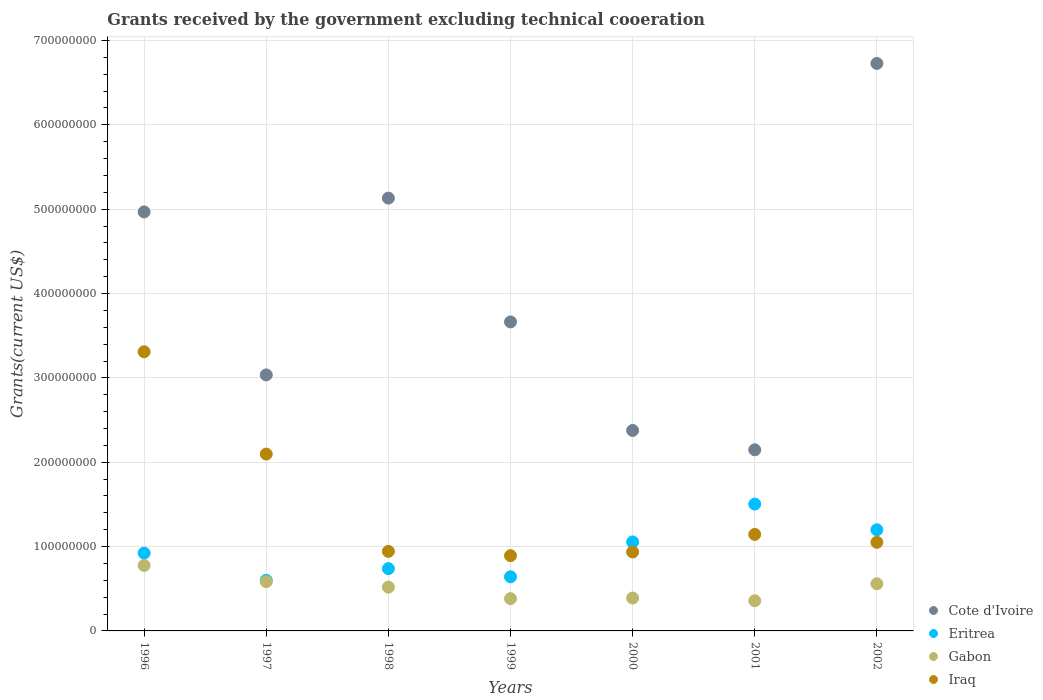How many different coloured dotlines are there?
Offer a terse response. 4. What is the total grants received by the government in Gabon in 1998?
Provide a succinct answer. 5.19e+07. Across all years, what is the maximum total grants received by the government in Iraq?
Your answer should be compact. 3.31e+08. Across all years, what is the minimum total grants received by the government in Eritrea?
Make the answer very short. 6.00e+07. In which year was the total grants received by the government in Iraq maximum?
Offer a terse response. 1996. What is the total total grants received by the government in Iraq in the graph?
Keep it short and to the point. 1.04e+09. What is the difference between the total grants received by the government in Gabon in 1998 and that in 1999?
Ensure brevity in your answer.  1.36e+07. What is the difference between the total grants received by the government in Eritrea in 1999 and the total grants received by the government in Gabon in 1996?
Offer a very short reply. -1.34e+07. What is the average total grants received by the government in Iraq per year?
Keep it short and to the point. 1.48e+08. In the year 2000, what is the difference between the total grants received by the government in Iraq and total grants received by the government in Gabon?
Your answer should be compact. 5.46e+07. What is the ratio of the total grants received by the government in Gabon in 1996 to that in 1999?
Ensure brevity in your answer.  2.03. Is the total grants received by the government in Gabon in 1997 less than that in 1998?
Ensure brevity in your answer.  No. What is the difference between the highest and the second highest total grants received by the government in Cote d'Ivoire?
Keep it short and to the point. 1.60e+08. What is the difference between the highest and the lowest total grants received by the government in Gabon?
Your answer should be compact. 4.18e+07. Is it the case that in every year, the sum of the total grants received by the government in Iraq and total grants received by the government in Eritrea  is greater than the total grants received by the government in Cote d'Ivoire?
Your answer should be compact. No. Does the total grants received by the government in Iraq monotonically increase over the years?
Your answer should be very brief. No. How many dotlines are there?
Make the answer very short. 4. How many years are there in the graph?
Offer a very short reply. 7. Are the values on the major ticks of Y-axis written in scientific E-notation?
Your response must be concise. No. Does the graph contain any zero values?
Make the answer very short. No. How are the legend labels stacked?
Keep it short and to the point. Vertical. What is the title of the graph?
Your response must be concise. Grants received by the government excluding technical cooeration. What is the label or title of the X-axis?
Offer a very short reply. Years. What is the label or title of the Y-axis?
Offer a very short reply. Grants(current US$). What is the Grants(current US$) in Cote d'Ivoire in 1996?
Offer a terse response. 4.97e+08. What is the Grants(current US$) in Eritrea in 1996?
Your answer should be very brief. 9.22e+07. What is the Grants(current US$) in Gabon in 1996?
Ensure brevity in your answer.  7.76e+07. What is the Grants(current US$) in Iraq in 1996?
Your answer should be very brief. 3.31e+08. What is the Grants(current US$) in Cote d'Ivoire in 1997?
Provide a short and direct response. 3.04e+08. What is the Grants(current US$) in Eritrea in 1997?
Ensure brevity in your answer.  6.00e+07. What is the Grants(current US$) in Gabon in 1997?
Provide a succinct answer. 5.84e+07. What is the Grants(current US$) in Iraq in 1997?
Your response must be concise. 2.10e+08. What is the Grants(current US$) in Cote d'Ivoire in 1998?
Offer a terse response. 5.13e+08. What is the Grants(current US$) of Eritrea in 1998?
Your answer should be very brief. 7.39e+07. What is the Grants(current US$) in Gabon in 1998?
Give a very brief answer. 5.19e+07. What is the Grants(current US$) of Iraq in 1998?
Give a very brief answer. 9.43e+07. What is the Grants(current US$) in Cote d'Ivoire in 1999?
Provide a succinct answer. 3.66e+08. What is the Grants(current US$) of Eritrea in 1999?
Offer a very short reply. 6.42e+07. What is the Grants(current US$) of Gabon in 1999?
Provide a succinct answer. 3.83e+07. What is the Grants(current US$) of Iraq in 1999?
Make the answer very short. 8.92e+07. What is the Grants(current US$) in Cote d'Ivoire in 2000?
Give a very brief answer. 2.38e+08. What is the Grants(current US$) in Eritrea in 2000?
Your answer should be compact. 1.06e+08. What is the Grants(current US$) in Gabon in 2000?
Your answer should be very brief. 3.90e+07. What is the Grants(current US$) of Iraq in 2000?
Your answer should be compact. 9.36e+07. What is the Grants(current US$) of Cote d'Ivoire in 2001?
Keep it short and to the point. 2.15e+08. What is the Grants(current US$) of Eritrea in 2001?
Ensure brevity in your answer.  1.50e+08. What is the Grants(current US$) of Gabon in 2001?
Provide a succinct answer. 3.58e+07. What is the Grants(current US$) of Iraq in 2001?
Ensure brevity in your answer.  1.14e+08. What is the Grants(current US$) of Cote d'Ivoire in 2002?
Your answer should be compact. 6.73e+08. What is the Grants(current US$) of Eritrea in 2002?
Keep it short and to the point. 1.20e+08. What is the Grants(current US$) of Gabon in 2002?
Keep it short and to the point. 5.59e+07. What is the Grants(current US$) of Iraq in 2002?
Your answer should be compact. 1.05e+08. Across all years, what is the maximum Grants(current US$) in Cote d'Ivoire?
Provide a short and direct response. 6.73e+08. Across all years, what is the maximum Grants(current US$) of Eritrea?
Ensure brevity in your answer.  1.50e+08. Across all years, what is the maximum Grants(current US$) in Gabon?
Your response must be concise. 7.76e+07. Across all years, what is the maximum Grants(current US$) of Iraq?
Ensure brevity in your answer.  3.31e+08. Across all years, what is the minimum Grants(current US$) of Cote d'Ivoire?
Keep it short and to the point. 2.15e+08. Across all years, what is the minimum Grants(current US$) in Eritrea?
Your answer should be compact. 6.00e+07. Across all years, what is the minimum Grants(current US$) of Gabon?
Provide a short and direct response. 3.58e+07. Across all years, what is the minimum Grants(current US$) in Iraq?
Offer a very short reply. 8.92e+07. What is the total Grants(current US$) in Cote d'Ivoire in the graph?
Ensure brevity in your answer.  2.81e+09. What is the total Grants(current US$) of Eritrea in the graph?
Ensure brevity in your answer.  6.66e+08. What is the total Grants(current US$) of Gabon in the graph?
Offer a terse response. 3.57e+08. What is the total Grants(current US$) of Iraq in the graph?
Your answer should be compact. 1.04e+09. What is the difference between the Grants(current US$) of Cote d'Ivoire in 1996 and that in 1997?
Your answer should be very brief. 1.93e+08. What is the difference between the Grants(current US$) of Eritrea in 1996 and that in 1997?
Ensure brevity in your answer.  3.22e+07. What is the difference between the Grants(current US$) in Gabon in 1996 and that in 1997?
Give a very brief answer. 1.92e+07. What is the difference between the Grants(current US$) in Iraq in 1996 and that in 1997?
Provide a succinct answer. 1.21e+08. What is the difference between the Grants(current US$) in Cote d'Ivoire in 1996 and that in 1998?
Your answer should be compact. -1.64e+07. What is the difference between the Grants(current US$) in Eritrea in 1996 and that in 1998?
Provide a short and direct response. 1.84e+07. What is the difference between the Grants(current US$) of Gabon in 1996 and that in 1998?
Keep it short and to the point. 2.57e+07. What is the difference between the Grants(current US$) in Iraq in 1996 and that in 1998?
Give a very brief answer. 2.37e+08. What is the difference between the Grants(current US$) of Cote d'Ivoire in 1996 and that in 1999?
Your answer should be compact. 1.30e+08. What is the difference between the Grants(current US$) in Eritrea in 1996 and that in 1999?
Offer a terse response. 2.81e+07. What is the difference between the Grants(current US$) of Gabon in 1996 and that in 1999?
Your response must be concise. 3.94e+07. What is the difference between the Grants(current US$) of Iraq in 1996 and that in 1999?
Your answer should be very brief. 2.42e+08. What is the difference between the Grants(current US$) of Cote d'Ivoire in 1996 and that in 2000?
Keep it short and to the point. 2.59e+08. What is the difference between the Grants(current US$) in Eritrea in 1996 and that in 2000?
Provide a succinct answer. -1.33e+07. What is the difference between the Grants(current US$) in Gabon in 1996 and that in 2000?
Keep it short and to the point. 3.86e+07. What is the difference between the Grants(current US$) of Iraq in 1996 and that in 2000?
Your answer should be compact. 2.37e+08. What is the difference between the Grants(current US$) of Cote d'Ivoire in 1996 and that in 2001?
Keep it short and to the point. 2.82e+08. What is the difference between the Grants(current US$) of Eritrea in 1996 and that in 2001?
Your answer should be compact. -5.82e+07. What is the difference between the Grants(current US$) in Gabon in 1996 and that in 2001?
Give a very brief answer. 4.18e+07. What is the difference between the Grants(current US$) of Iraq in 1996 and that in 2001?
Make the answer very short. 2.17e+08. What is the difference between the Grants(current US$) in Cote d'Ivoire in 1996 and that in 2002?
Provide a succinct answer. -1.76e+08. What is the difference between the Grants(current US$) in Eritrea in 1996 and that in 2002?
Keep it short and to the point. -2.77e+07. What is the difference between the Grants(current US$) of Gabon in 1996 and that in 2002?
Make the answer very short. 2.17e+07. What is the difference between the Grants(current US$) of Iraq in 1996 and that in 2002?
Give a very brief answer. 2.26e+08. What is the difference between the Grants(current US$) in Cote d'Ivoire in 1997 and that in 1998?
Ensure brevity in your answer.  -2.10e+08. What is the difference between the Grants(current US$) of Eritrea in 1997 and that in 1998?
Provide a short and direct response. -1.38e+07. What is the difference between the Grants(current US$) in Gabon in 1997 and that in 1998?
Your answer should be compact. 6.46e+06. What is the difference between the Grants(current US$) of Iraq in 1997 and that in 1998?
Your answer should be very brief. 1.15e+08. What is the difference between the Grants(current US$) in Cote d'Ivoire in 1997 and that in 1999?
Your answer should be very brief. -6.28e+07. What is the difference between the Grants(current US$) of Eritrea in 1997 and that in 1999?
Offer a terse response. -4.17e+06. What is the difference between the Grants(current US$) of Gabon in 1997 and that in 1999?
Keep it short and to the point. 2.01e+07. What is the difference between the Grants(current US$) in Iraq in 1997 and that in 1999?
Make the answer very short. 1.20e+08. What is the difference between the Grants(current US$) of Cote d'Ivoire in 1997 and that in 2000?
Your answer should be very brief. 6.59e+07. What is the difference between the Grants(current US$) of Eritrea in 1997 and that in 2000?
Your response must be concise. -4.55e+07. What is the difference between the Grants(current US$) of Gabon in 1997 and that in 2000?
Provide a succinct answer. 1.94e+07. What is the difference between the Grants(current US$) of Iraq in 1997 and that in 2000?
Offer a very short reply. 1.16e+08. What is the difference between the Grants(current US$) in Cote d'Ivoire in 1997 and that in 2001?
Offer a terse response. 8.88e+07. What is the difference between the Grants(current US$) of Eritrea in 1997 and that in 2001?
Offer a terse response. -9.04e+07. What is the difference between the Grants(current US$) of Gabon in 1997 and that in 2001?
Make the answer very short. 2.26e+07. What is the difference between the Grants(current US$) of Iraq in 1997 and that in 2001?
Provide a short and direct response. 9.52e+07. What is the difference between the Grants(current US$) of Cote d'Ivoire in 1997 and that in 2002?
Keep it short and to the point. -3.69e+08. What is the difference between the Grants(current US$) in Eritrea in 1997 and that in 2002?
Give a very brief answer. -5.99e+07. What is the difference between the Grants(current US$) in Gabon in 1997 and that in 2002?
Your answer should be very brief. 2.47e+06. What is the difference between the Grants(current US$) in Iraq in 1997 and that in 2002?
Keep it short and to the point. 1.05e+08. What is the difference between the Grants(current US$) in Cote d'Ivoire in 1998 and that in 1999?
Your answer should be compact. 1.47e+08. What is the difference between the Grants(current US$) in Eritrea in 1998 and that in 1999?
Offer a very short reply. 9.68e+06. What is the difference between the Grants(current US$) in Gabon in 1998 and that in 1999?
Your answer should be very brief. 1.36e+07. What is the difference between the Grants(current US$) of Iraq in 1998 and that in 1999?
Your response must be concise. 5.11e+06. What is the difference between the Grants(current US$) of Cote d'Ivoire in 1998 and that in 2000?
Give a very brief answer. 2.75e+08. What is the difference between the Grants(current US$) in Eritrea in 1998 and that in 2000?
Your answer should be very brief. -3.17e+07. What is the difference between the Grants(current US$) in Gabon in 1998 and that in 2000?
Offer a terse response. 1.29e+07. What is the difference between the Grants(current US$) of Iraq in 1998 and that in 2000?
Make the answer very short. 7.00e+05. What is the difference between the Grants(current US$) of Cote d'Ivoire in 1998 and that in 2001?
Offer a terse response. 2.98e+08. What is the difference between the Grants(current US$) in Eritrea in 1998 and that in 2001?
Your answer should be compact. -7.66e+07. What is the difference between the Grants(current US$) of Gabon in 1998 and that in 2001?
Your response must be concise. 1.61e+07. What is the difference between the Grants(current US$) in Iraq in 1998 and that in 2001?
Offer a very short reply. -2.01e+07. What is the difference between the Grants(current US$) of Cote d'Ivoire in 1998 and that in 2002?
Provide a succinct answer. -1.60e+08. What is the difference between the Grants(current US$) of Eritrea in 1998 and that in 2002?
Your answer should be compact. -4.61e+07. What is the difference between the Grants(current US$) of Gabon in 1998 and that in 2002?
Give a very brief answer. -3.99e+06. What is the difference between the Grants(current US$) in Iraq in 1998 and that in 2002?
Offer a very short reply. -1.07e+07. What is the difference between the Grants(current US$) in Cote d'Ivoire in 1999 and that in 2000?
Ensure brevity in your answer.  1.29e+08. What is the difference between the Grants(current US$) of Eritrea in 1999 and that in 2000?
Your response must be concise. -4.13e+07. What is the difference between the Grants(current US$) of Gabon in 1999 and that in 2000?
Your answer should be very brief. -7.00e+05. What is the difference between the Grants(current US$) of Iraq in 1999 and that in 2000?
Give a very brief answer. -4.41e+06. What is the difference between the Grants(current US$) of Cote d'Ivoire in 1999 and that in 2001?
Ensure brevity in your answer.  1.52e+08. What is the difference between the Grants(current US$) in Eritrea in 1999 and that in 2001?
Keep it short and to the point. -8.62e+07. What is the difference between the Grants(current US$) of Gabon in 1999 and that in 2001?
Offer a very short reply. 2.50e+06. What is the difference between the Grants(current US$) in Iraq in 1999 and that in 2001?
Offer a terse response. -2.52e+07. What is the difference between the Grants(current US$) in Cote d'Ivoire in 1999 and that in 2002?
Your response must be concise. -3.06e+08. What is the difference between the Grants(current US$) in Eritrea in 1999 and that in 2002?
Your response must be concise. -5.58e+07. What is the difference between the Grants(current US$) of Gabon in 1999 and that in 2002?
Your answer should be very brief. -1.76e+07. What is the difference between the Grants(current US$) in Iraq in 1999 and that in 2002?
Your response must be concise. -1.58e+07. What is the difference between the Grants(current US$) in Cote d'Ivoire in 2000 and that in 2001?
Give a very brief answer. 2.30e+07. What is the difference between the Grants(current US$) of Eritrea in 2000 and that in 2001?
Make the answer very short. -4.49e+07. What is the difference between the Grants(current US$) in Gabon in 2000 and that in 2001?
Your answer should be very brief. 3.20e+06. What is the difference between the Grants(current US$) of Iraq in 2000 and that in 2001?
Keep it short and to the point. -2.08e+07. What is the difference between the Grants(current US$) in Cote d'Ivoire in 2000 and that in 2002?
Provide a succinct answer. -4.35e+08. What is the difference between the Grants(current US$) of Eritrea in 2000 and that in 2002?
Keep it short and to the point. -1.44e+07. What is the difference between the Grants(current US$) of Gabon in 2000 and that in 2002?
Offer a terse response. -1.69e+07. What is the difference between the Grants(current US$) in Iraq in 2000 and that in 2002?
Give a very brief answer. -1.14e+07. What is the difference between the Grants(current US$) of Cote d'Ivoire in 2001 and that in 2002?
Keep it short and to the point. -4.58e+08. What is the difference between the Grants(current US$) in Eritrea in 2001 and that in 2002?
Make the answer very short. 3.05e+07. What is the difference between the Grants(current US$) in Gabon in 2001 and that in 2002?
Give a very brief answer. -2.01e+07. What is the difference between the Grants(current US$) in Iraq in 2001 and that in 2002?
Offer a very short reply. 9.41e+06. What is the difference between the Grants(current US$) in Cote d'Ivoire in 1996 and the Grants(current US$) in Eritrea in 1997?
Ensure brevity in your answer.  4.37e+08. What is the difference between the Grants(current US$) in Cote d'Ivoire in 1996 and the Grants(current US$) in Gabon in 1997?
Your answer should be compact. 4.38e+08. What is the difference between the Grants(current US$) of Cote d'Ivoire in 1996 and the Grants(current US$) of Iraq in 1997?
Ensure brevity in your answer.  2.87e+08. What is the difference between the Grants(current US$) of Eritrea in 1996 and the Grants(current US$) of Gabon in 1997?
Your answer should be compact. 3.39e+07. What is the difference between the Grants(current US$) of Eritrea in 1996 and the Grants(current US$) of Iraq in 1997?
Offer a very short reply. -1.17e+08. What is the difference between the Grants(current US$) of Gabon in 1996 and the Grants(current US$) of Iraq in 1997?
Ensure brevity in your answer.  -1.32e+08. What is the difference between the Grants(current US$) in Cote d'Ivoire in 1996 and the Grants(current US$) in Eritrea in 1998?
Provide a short and direct response. 4.23e+08. What is the difference between the Grants(current US$) of Cote d'Ivoire in 1996 and the Grants(current US$) of Gabon in 1998?
Provide a succinct answer. 4.45e+08. What is the difference between the Grants(current US$) in Cote d'Ivoire in 1996 and the Grants(current US$) in Iraq in 1998?
Your answer should be compact. 4.02e+08. What is the difference between the Grants(current US$) of Eritrea in 1996 and the Grants(current US$) of Gabon in 1998?
Your response must be concise. 4.03e+07. What is the difference between the Grants(current US$) in Eritrea in 1996 and the Grants(current US$) in Iraq in 1998?
Provide a short and direct response. -2.05e+06. What is the difference between the Grants(current US$) of Gabon in 1996 and the Grants(current US$) of Iraq in 1998?
Give a very brief answer. -1.67e+07. What is the difference between the Grants(current US$) in Cote d'Ivoire in 1996 and the Grants(current US$) in Eritrea in 1999?
Your answer should be very brief. 4.33e+08. What is the difference between the Grants(current US$) of Cote d'Ivoire in 1996 and the Grants(current US$) of Gabon in 1999?
Give a very brief answer. 4.58e+08. What is the difference between the Grants(current US$) in Cote d'Ivoire in 1996 and the Grants(current US$) in Iraq in 1999?
Your answer should be compact. 4.08e+08. What is the difference between the Grants(current US$) of Eritrea in 1996 and the Grants(current US$) of Gabon in 1999?
Offer a terse response. 5.40e+07. What is the difference between the Grants(current US$) of Eritrea in 1996 and the Grants(current US$) of Iraq in 1999?
Provide a short and direct response. 3.06e+06. What is the difference between the Grants(current US$) of Gabon in 1996 and the Grants(current US$) of Iraq in 1999?
Your answer should be compact. -1.16e+07. What is the difference between the Grants(current US$) in Cote d'Ivoire in 1996 and the Grants(current US$) in Eritrea in 2000?
Provide a succinct answer. 3.91e+08. What is the difference between the Grants(current US$) in Cote d'Ivoire in 1996 and the Grants(current US$) in Gabon in 2000?
Provide a short and direct response. 4.58e+08. What is the difference between the Grants(current US$) of Cote d'Ivoire in 1996 and the Grants(current US$) of Iraq in 2000?
Provide a succinct answer. 4.03e+08. What is the difference between the Grants(current US$) of Eritrea in 1996 and the Grants(current US$) of Gabon in 2000?
Your answer should be very brief. 5.33e+07. What is the difference between the Grants(current US$) in Eritrea in 1996 and the Grants(current US$) in Iraq in 2000?
Give a very brief answer. -1.35e+06. What is the difference between the Grants(current US$) in Gabon in 1996 and the Grants(current US$) in Iraq in 2000?
Provide a short and direct response. -1.60e+07. What is the difference between the Grants(current US$) in Cote d'Ivoire in 1996 and the Grants(current US$) in Eritrea in 2001?
Offer a terse response. 3.46e+08. What is the difference between the Grants(current US$) of Cote d'Ivoire in 1996 and the Grants(current US$) of Gabon in 2001?
Offer a very short reply. 4.61e+08. What is the difference between the Grants(current US$) of Cote d'Ivoire in 1996 and the Grants(current US$) of Iraq in 2001?
Offer a terse response. 3.82e+08. What is the difference between the Grants(current US$) in Eritrea in 1996 and the Grants(current US$) in Gabon in 2001?
Your response must be concise. 5.65e+07. What is the difference between the Grants(current US$) in Eritrea in 1996 and the Grants(current US$) in Iraq in 2001?
Your answer should be compact. -2.22e+07. What is the difference between the Grants(current US$) of Gabon in 1996 and the Grants(current US$) of Iraq in 2001?
Provide a short and direct response. -3.68e+07. What is the difference between the Grants(current US$) of Cote d'Ivoire in 1996 and the Grants(current US$) of Eritrea in 2002?
Your response must be concise. 3.77e+08. What is the difference between the Grants(current US$) in Cote d'Ivoire in 1996 and the Grants(current US$) in Gabon in 2002?
Offer a very short reply. 4.41e+08. What is the difference between the Grants(current US$) in Cote d'Ivoire in 1996 and the Grants(current US$) in Iraq in 2002?
Your answer should be compact. 3.92e+08. What is the difference between the Grants(current US$) of Eritrea in 1996 and the Grants(current US$) of Gabon in 2002?
Make the answer very short. 3.63e+07. What is the difference between the Grants(current US$) in Eritrea in 1996 and the Grants(current US$) in Iraq in 2002?
Ensure brevity in your answer.  -1.28e+07. What is the difference between the Grants(current US$) of Gabon in 1996 and the Grants(current US$) of Iraq in 2002?
Your response must be concise. -2.74e+07. What is the difference between the Grants(current US$) of Cote d'Ivoire in 1997 and the Grants(current US$) of Eritrea in 1998?
Provide a short and direct response. 2.30e+08. What is the difference between the Grants(current US$) in Cote d'Ivoire in 1997 and the Grants(current US$) in Gabon in 1998?
Offer a very short reply. 2.52e+08. What is the difference between the Grants(current US$) in Cote d'Ivoire in 1997 and the Grants(current US$) in Iraq in 1998?
Provide a succinct answer. 2.09e+08. What is the difference between the Grants(current US$) of Eritrea in 1997 and the Grants(current US$) of Gabon in 1998?
Your response must be concise. 8.09e+06. What is the difference between the Grants(current US$) of Eritrea in 1997 and the Grants(current US$) of Iraq in 1998?
Keep it short and to the point. -3.43e+07. What is the difference between the Grants(current US$) in Gabon in 1997 and the Grants(current US$) in Iraq in 1998?
Provide a short and direct response. -3.59e+07. What is the difference between the Grants(current US$) in Cote d'Ivoire in 1997 and the Grants(current US$) in Eritrea in 1999?
Offer a very short reply. 2.39e+08. What is the difference between the Grants(current US$) of Cote d'Ivoire in 1997 and the Grants(current US$) of Gabon in 1999?
Offer a terse response. 2.65e+08. What is the difference between the Grants(current US$) of Cote d'Ivoire in 1997 and the Grants(current US$) of Iraq in 1999?
Provide a short and direct response. 2.14e+08. What is the difference between the Grants(current US$) in Eritrea in 1997 and the Grants(current US$) in Gabon in 1999?
Your answer should be very brief. 2.17e+07. What is the difference between the Grants(current US$) in Eritrea in 1997 and the Grants(current US$) in Iraq in 1999?
Your answer should be compact. -2.92e+07. What is the difference between the Grants(current US$) of Gabon in 1997 and the Grants(current US$) of Iraq in 1999?
Ensure brevity in your answer.  -3.08e+07. What is the difference between the Grants(current US$) in Cote d'Ivoire in 1997 and the Grants(current US$) in Eritrea in 2000?
Offer a terse response. 1.98e+08. What is the difference between the Grants(current US$) of Cote d'Ivoire in 1997 and the Grants(current US$) of Gabon in 2000?
Ensure brevity in your answer.  2.65e+08. What is the difference between the Grants(current US$) of Cote d'Ivoire in 1997 and the Grants(current US$) of Iraq in 2000?
Ensure brevity in your answer.  2.10e+08. What is the difference between the Grants(current US$) of Eritrea in 1997 and the Grants(current US$) of Gabon in 2000?
Keep it short and to the point. 2.10e+07. What is the difference between the Grants(current US$) in Eritrea in 1997 and the Grants(current US$) in Iraq in 2000?
Your answer should be compact. -3.36e+07. What is the difference between the Grants(current US$) in Gabon in 1997 and the Grants(current US$) in Iraq in 2000?
Provide a succinct answer. -3.52e+07. What is the difference between the Grants(current US$) of Cote d'Ivoire in 1997 and the Grants(current US$) of Eritrea in 2001?
Ensure brevity in your answer.  1.53e+08. What is the difference between the Grants(current US$) in Cote d'Ivoire in 1997 and the Grants(current US$) in Gabon in 2001?
Provide a short and direct response. 2.68e+08. What is the difference between the Grants(current US$) in Cote d'Ivoire in 1997 and the Grants(current US$) in Iraq in 2001?
Keep it short and to the point. 1.89e+08. What is the difference between the Grants(current US$) of Eritrea in 1997 and the Grants(current US$) of Gabon in 2001?
Provide a succinct answer. 2.42e+07. What is the difference between the Grants(current US$) in Eritrea in 1997 and the Grants(current US$) in Iraq in 2001?
Provide a short and direct response. -5.44e+07. What is the difference between the Grants(current US$) in Gabon in 1997 and the Grants(current US$) in Iraq in 2001?
Give a very brief answer. -5.61e+07. What is the difference between the Grants(current US$) in Cote d'Ivoire in 1997 and the Grants(current US$) in Eritrea in 2002?
Keep it short and to the point. 1.84e+08. What is the difference between the Grants(current US$) in Cote d'Ivoire in 1997 and the Grants(current US$) in Gabon in 2002?
Your response must be concise. 2.48e+08. What is the difference between the Grants(current US$) in Cote d'Ivoire in 1997 and the Grants(current US$) in Iraq in 2002?
Offer a terse response. 1.99e+08. What is the difference between the Grants(current US$) in Eritrea in 1997 and the Grants(current US$) in Gabon in 2002?
Your answer should be very brief. 4.10e+06. What is the difference between the Grants(current US$) of Eritrea in 1997 and the Grants(current US$) of Iraq in 2002?
Make the answer very short. -4.50e+07. What is the difference between the Grants(current US$) in Gabon in 1997 and the Grants(current US$) in Iraq in 2002?
Your answer should be compact. -4.66e+07. What is the difference between the Grants(current US$) in Cote d'Ivoire in 1998 and the Grants(current US$) in Eritrea in 1999?
Make the answer very short. 4.49e+08. What is the difference between the Grants(current US$) in Cote d'Ivoire in 1998 and the Grants(current US$) in Gabon in 1999?
Offer a very short reply. 4.75e+08. What is the difference between the Grants(current US$) of Cote d'Ivoire in 1998 and the Grants(current US$) of Iraq in 1999?
Offer a very short reply. 4.24e+08. What is the difference between the Grants(current US$) in Eritrea in 1998 and the Grants(current US$) in Gabon in 1999?
Your answer should be very brief. 3.56e+07. What is the difference between the Grants(current US$) in Eritrea in 1998 and the Grants(current US$) in Iraq in 1999?
Offer a very short reply. -1.53e+07. What is the difference between the Grants(current US$) of Gabon in 1998 and the Grants(current US$) of Iraq in 1999?
Offer a very short reply. -3.73e+07. What is the difference between the Grants(current US$) of Cote d'Ivoire in 1998 and the Grants(current US$) of Eritrea in 2000?
Your response must be concise. 4.08e+08. What is the difference between the Grants(current US$) in Cote d'Ivoire in 1998 and the Grants(current US$) in Gabon in 2000?
Your answer should be compact. 4.74e+08. What is the difference between the Grants(current US$) of Cote d'Ivoire in 1998 and the Grants(current US$) of Iraq in 2000?
Keep it short and to the point. 4.20e+08. What is the difference between the Grants(current US$) of Eritrea in 1998 and the Grants(current US$) of Gabon in 2000?
Your answer should be very brief. 3.49e+07. What is the difference between the Grants(current US$) in Eritrea in 1998 and the Grants(current US$) in Iraq in 2000?
Offer a terse response. -1.97e+07. What is the difference between the Grants(current US$) of Gabon in 1998 and the Grants(current US$) of Iraq in 2000?
Give a very brief answer. -4.17e+07. What is the difference between the Grants(current US$) of Cote d'Ivoire in 1998 and the Grants(current US$) of Eritrea in 2001?
Keep it short and to the point. 3.63e+08. What is the difference between the Grants(current US$) in Cote d'Ivoire in 1998 and the Grants(current US$) in Gabon in 2001?
Your response must be concise. 4.77e+08. What is the difference between the Grants(current US$) in Cote d'Ivoire in 1998 and the Grants(current US$) in Iraq in 2001?
Give a very brief answer. 3.99e+08. What is the difference between the Grants(current US$) in Eritrea in 1998 and the Grants(current US$) in Gabon in 2001?
Keep it short and to the point. 3.81e+07. What is the difference between the Grants(current US$) of Eritrea in 1998 and the Grants(current US$) of Iraq in 2001?
Keep it short and to the point. -4.06e+07. What is the difference between the Grants(current US$) in Gabon in 1998 and the Grants(current US$) in Iraq in 2001?
Keep it short and to the point. -6.25e+07. What is the difference between the Grants(current US$) in Cote d'Ivoire in 1998 and the Grants(current US$) in Eritrea in 2002?
Give a very brief answer. 3.93e+08. What is the difference between the Grants(current US$) in Cote d'Ivoire in 1998 and the Grants(current US$) in Gabon in 2002?
Offer a very short reply. 4.57e+08. What is the difference between the Grants(current US$) of Cote d'Ivoire in 1998 and the Grants(current US$) of Iraq in 2002?
Make the answer very short. 4.08e+08. What is the difference between the Grants(current US$) in Eritrea in 1998 and the Grants(current US$) in Gabon in 2002?
Provide a short and direct response. 1.80e+07. What is the difference between the Grants(current US$) in Eritrea in 1998 and the Grants(current US$) in Iraq in 2002?
Ensure brevity in your answer.  -3.12e+07. What is the difference between the Grants(current US$) of Gabon in 1998 and the Grants(current US$) of Iraq in 2002?
Offer a very short reply. -5.31e+07. What is the difference between the Grants(current US$) of Cote d'Ivoire in 1999 and the Grants(current US$) of Eritrea in 2000?
Make the answer very short. 2.61e+08. What is the difference between the Grants(current US$) in Cote d'Ivoire in 1999 and the Grants(current US$) in Gabon in 2000?
Offer a very short reply. 3.27e+08. What is the difference between the Grants(current US$) in Cote d'Ivoire in 1999 and the Grants(current US$) in Iraq in 2000?
Provide a succinct answer. 2.73e+08. What is the difference between the Grants(current US$) in Eritrea in 1999 and the Grants(current US$) in Gabon in 2000?
Provide a succinct answer. 2.52e+07. What is the difference between the Grants(current US$) of Eritrea in 1999 and the Grants(current US$) of Iraq in 2000?
Your answer should be very brief. -2.94e+07. What is the difference between the Grants(current US$) of Gabon in 1999 and the Grants(current US$) of Iraq in 2000?
Ensure brevity in your answer.  -5.53e+07. What is the difference between the Grants(current US$) of Cote d'Ivoire in 1999 and the Grants(current US$) of Eritrea in 2001?
Your response must be concise. 2.16e+08. What is the difference between the Grants(current US$) of Cote d'Ivoire in 1999 and the Grants(current US$) of Gabon in 2001?
Your answer should be very brief. 3.31e+08. What is the difference between the Grants(current US$) of Cote d'Ivoire in 1999 and the Grants(current US$) of Iraq in 2001?
Keep it short and to the point. 2.52e+08. What is the difference between the Grants(current US$) in Eritrea in 1999 and the Grants(current US$) in Gabon in 2001?
Offer a terse response. 2.84e+07. What is the difference between the Grants(current US$) in Eritrea in 1999 and the Grants(current US$) in Iraq in 2001?
Your answer should be compact. -5.03e+07. What is the difference between the Grants(current US$) of Gabon in 1999 and the Grants(current US$) of Iraq in 2001?
Give a very brief answer. -7.62e+07. What is the difference between the Grants(current US$) in Cote d'Ivoire in 1999 and the Grants(current US$) in Eritrea in 2002?
Your response must be concise. 2.46e+08. What is the difference between the Grants(current US$) in Cote d'Ivoire in 1999 and the Grants(current US$) in Gabon in 2002?
Ensure brevity in your answer.  3.10e+08. What is the difference between the Grants(current US$) in Cote d'Ivoire in 1999 and the Grants(current US$) in Iraq in 2002?
Ensure brevity in your answer.  2.61e+08. What is the difference between the Grants(current US$) in Eritrea in 1999 and the Grants(current US$) in Gabon in 2002?
Give a very brief answer. 8.27e+06. What is the difference between the Grants(current US$) in Eritrea in 1999 and the Grants(current US$) in Iraq in 2002?
Your response must be concise. -4.08e+07. What is the difference between the Grants(current US$) of Gabon in 1999 and the Grants(current US$) of Iraq in 2002?
Offer a terse response. -6.68e+07. What is the difference between the Grants(current US$) of Cote d'Ivoire in 2000 and the Grants(current US$) of Eritrea in 2001?
Your answer should be very brief. 8.73e+07. What is the difference between the Grants(current US$) in Cote d'Ivoire in 2000 and the Grants(current US$) in Gabon in 2001?
Offer a terse response. 2.02e+08. What is the difference between the Grants(current US$) of Cote d'Ivoire in 2000 and the Grants(current US$) of Iraq in 2001?
Offer a terse response. 1.23e+08. What is the difference between the Grants(current US$) in Eritrea in 2000 and the Grants(current US$) in Gabon in 2001?
Ensure brevity in your answer.  6.97e+07. What is the difference between the Grants(current US$) of Eritrea in 2000 and the Grants(current US$) of Iraq in 2001?
Offer a terse response. -8.92e+06. What is the difference between the Grants(current US$) of Gabon in 2000 and the Grants(current US$) of Iraq in 2001?
Provide a succinct answer. -7.55e+07. What is the difference between the Grants(current US$) of Cote d'Ivoire in 2000 and the Grants(current US$) of Eritrea in 2002?
Offer a terse response. 1.18e+08. What is the difference between the Grants(current US$) in Cote d'Ivoire in 2000 and the Grants(current US$) in Gabon in 2002?
Make the answer very short. 1.82e+08. What is the difference between the Grants(current US$) in Cote d'Ivoire in 2000 and the Grants(current US$) in Iraq in 2002?
Provide a short and direct response. 1.33e+08. What is the difference between the Grants(current US$) in Eritrea in 2000 and the Grants(current US$) in Gabon in 2002?
Give a very brief answer. 4.96e+07. What is the difference between the Grants(current US$) in Gabon in 2000 and the Grants(current US$) in Iraq in 2002?
Your response must be concise. -6.60e+07. What is the difference between the Grants(current US$) of Cote d'Ivoire in 2001 and the Grants(current US$) of Eritrea in 2002?
Offer a very short reply. 9.48e+07. What is the difference between the Grants(current US$) in Cote d'Ivoire in 2001 and the Grants(current US$) in Gabon in 2002?
Keep it short and to the point. 1.59e+08. What is the difference between the Grants(current US$) of Cote d'Ivoire in 2001 and the Grants(current US$) of Iraq in 2002?
Provide a succinct answer. 1.10e+08. What is the difference between the Grants(current US$) in Eritrea in 2001 and the Grants(current US$) in Gabon in 2002?
Keep it short and to the point. 9.45e+07. What is the difference between the Grants(current US$) of Eritrea in 2001 and the Grants(current US$) of Iraq in 2002?
Give a very brief answer. 4.54e+07. What is the difference between the Grants(current US$) of Gabon in 2001 and the Grants(current US$) of Iraq in 2002?
Make the answer very short. -6.92e+07. What is the average Grants(current US$) in Cote d'Ivoire per year?
Ensure brevity in your answer.  4.01e+08. What is the average Grants(current US$) of Eritrea per year?
Offer a very short reply. 9.52e+07. What is the average Grants(current US$) in Gabon per year?
Give a very brief answer. 5.10e+07. What is the average Grants(current US$) of Iraq per year?
Make the answer very short. 1.48e+08. In the year 1996, what is the difference between the Grants(current US$) of Cote d'Ivoire and Grants(current US$) of Eritrea?
Ensure brevity in your answer.  4.05e+08. In the year 1996, what is the difference between the Grants(current US$) of Cote d'Ivoire and Grants(current US$) of Gabon?
Make the answer very short. 4.19e+08. In the year 1996, what is the difference between the Grants(current US$) of Cote d'Ivoire and Grants(current US$) of Iraq?
Your response must be concise. 1.66e+08. In the year 1996, what is the difference between the Grants(current US$) in Eritrea and Grants(current US$) in Gabon?
Your answer should be compact. 1.46e+07. In the year 1996, what is the difference between the Grants(current US$) in Eritrea and Grants(current US$) in Iraq?
Your answer should be very brief. -2.39e+08. In the year 1996, what is the difference between the Grants(current US$) of Gabon and Grants(current US$) of Iraq?
Make the answer very short. -2.53e+08. In the year 1997, what is the difference between the Grants(current US$) in Cote d'Ivoire and Grants(current US$) in Eritrea?
Your answer should be very brief. 2.44e+08. In the year 1997, what is the difference between the Grants(current US$) of Cote d'Ivoire and Grants(current US$) of Gabon?
Keep it short and to the point. 2.45e+08. In the year 1997, what is the difference between the Grants(current US$) in Cote d'Ivoire and Grants(current US$) in Iraq?
Make the answer very short. 9.39e+07. In the year 1997, what is the difference between the Grants(current US$) of Eritrea and Grants(current US$) of Gabon?
Your response must be concise. 1.63e+06. In the year 1997, what is the difference between the Grants(current US$) in Eritrea and Grants(current US$) in Iraq?
Ensure brevity in your answer.  -1.50e+08. In the year 1997, what is the difference between the Grants(current US$) in Gabon and Grants(current US$) in Iraq?
Provide a succinct answer. -1.51e+08. In the year 1998, what is the difference between the Grants(current US$) of Cote d'Ivoire and Grants(current US$) of Eritrea?
Offer a very short reply. 4.39e+08. In the year 1998, what is the difference between the Grants(current US$) in Cote d'Ivoire and Grants(current US$) in Gabon?
Your answer should be compact. 4.61e+08. In the year 1998, what is the difference between the Grants(current US$) in Cote d'Ivoire and Grants(current US$) in Iraq?
Your answer should be compact. 4.19e+08. In the year 1998, what is the difference between the Grants(current US$) of Eritrea and Grants(current US$) of Gabon?
Provide a succinct answer. 2.19e+07. In the year 1998, what is the difference between the Grants(current US$) of Eritrea and Grants(current US$) of Iraq?
Keep it short and to the point. -2.04e+07. In the year 1998, what is the difference between the Grants(current US$) in Gabon and Grants(current US$) in Iraq?
Your response must be concise. -4.24e+07. In the year 1999, what is the difference between the Grants(current US$) in Cote d'Ivoire and Grants(current US$) in Eritrea?
Provide a succinct answer. 3.02e+08. In the year 1999, what is the difference between the Grants(current US$) of Cote d'Ivoire and Grants(current US$) of Gabon?
Keep it short and to the point. 3.28e+08. In the year 1999, what is the difference between the Grants(current US$) of Cote d'Ivoire and Grants(current US$) of Iraq?
Your answer should be very brief. 2.77e+08. In the year 1999, what is the difference between the Grants(current US$) in Eritrea and Grants(current US$) in Gabon?
Ensure brevity in your answer.  2.59e+07. In the year 1999, what is the difference between the Grants(current US$) of Eritrea and Grants(current US$) of Iraq?
Your answer should be compact. -2.50e+07. In the year 1999, what is the difference between the Grants(current US$) in Gabon and Grants(current US$) in Iraq?
Your answer should be compact. -5.09e+07. In the year 2000, what is the difference between the Grants(current US$) in Cote d'Ivoire and Grants(current US$) in Eritrea?
Give a very brief answer. 1.32e+08. In the year 2000, what is the difference between the Grants(current US$) in Cote d'Ivoire and Grants(current US$) in Gabon?
Offer a very short reply. 1.99e+08. In the year 2000, what is the difference between the Grants(current US$) in Cote d'Ivoire and Grants(current US$) in Iraq?
Make the answer very short. 1.44e+08. In the year 2000, what is the difference between the Grants(current US$) of Eritrea and Grants(current US$) of Gabon?
Ensure brevity in your answer.  6.65e+07. In the year 2000, what is the difference between the Grants(current US$) in Eritrea and Grants(current US$) in Iraq?
Provide a short and direct response. 1.19e+07. In the year 2000, what is the difference between the Grants(current US$) in Gabon and Grants(current US$) in Iraq?
Keep it short and to the point. -5.46e+07. In the year 2001, what is the difference between the Grants(current US$) of Cote d'Ivoire and Grants(current US$) of Eritrea?
Keep it short and to the point. 6.43e+07. In the year 2001, what is the difference between the Grants(current US$) in Cote d'Ivoire and Grants(current US$) in Gabon?
Your answer should be very brief. 1.79e+08. In the year 2001, what is the difference between the Grants(current US$) in Cote d'Ivoire and Grants(current US$) in Iraq?
Make the answer very short. 1.00e+08. In the year 2001, what is the difference between the Grants(current US$) in Eritrea and Grants(current US$) in Gabon?
Offer a terse response. 1.15e+08. In the year 2001, what is the difference between the Grants(current US$) of Eritrea and Grants(current US$) of Iraq?
Provide a succinct answer. 3.60e+07. In the year 2001, what is the difference between the Grants(current US$) of Gabon and Grants(current US$) of Iraq?
Your response must be concise. -7.87e+07. In the year 2002, what is the difference between the Grants(current US$) of Cote d'Ivoire and Grants(current US$) of Eritrea?
Keep it short and to the point. 5.53e+08. In the year 2002, what is the difference between the Grants(current US$) in Cote d'Ivoire and Grants(current US$) in Gabon?
Ensure brevity in your answer.  6.17e+08. In the year 2002, what is the difference between the Grants(current US$) of Cote d'Ivoire and Grants(current US$) of Iraq?
Ensure brevity in your answer.  5.68e+08. In the year 2002, what is the difference between the Grants(current US$) in Eritrea and Grants(current US$) in Gabon?
Keep it short and to the point. 6.40e+07. In the year 2002, what is the difference between the Grants(current US$) in Eritrea and Grants(current US$) in Iraq?
Your response must be concise. 1.49e+07. In the year 2002, what is the difference between the Grants(current US$) of Gabon and Grants(current US$) of Iraq?
Your response must be concise. -4.91e+07. What is the ratio of the Grants(current US$) in Cote d'Ivoire in 1996 to that in 1997?
Your answer should be very brief. 1.64. What is the ratio of the Grants(current US$) of Eritrea in 1996 to that in 1997?
Ensure brevity in your answer.  1.54. What is the ratio of the Grants(current US$) in Gabon in 1996 to that in 1997?
Keep it short and to the point. 1.33. What is the ratio of the Grants(current US$) in Iraq in 1996 to that in 1997?
Offer a terse response. 1.58. What is the ratio of the Grants(current US$) in Cote d'Ivoire in 1996 to that in 1998?
Ensure brevity in your answer.  0.97. What is the ratio of the Grants(current US$) of Eritrea in 1996 to that in 1998?
Make the answer very short. 1.25. What is the ratio of the Grants(current US$) of Gabon in 1996 to that in 1998?
Offer a very short reply. 1.5. What is the ratio of the Grants(current US$) in Iraq in 1996 to that in 1998?
Offer a terse response. 3.51. What is the ratio of the Grants(current US$) of Cote d'Ivoire in 1996 to that in 1999?
Offer a terse response. 1.36. What is the ratio of the Grants(current US$) in Eritrea in 1996 to that in 1999?
Provide a succinct answer. 1.44. What is the ratio of the Grants(current US$) in Gabon in 1996 to that in 1999?
Provide a short and direct response. 2.03. What is the ratio of the Grants(current US$) of Iraq in 1996 to that in 1999?
Offer a terse response. 3.71. What is the ratio of the Grants(current US$) of Cote d'Ivoire in 1996 to that in 2000?
Ensure brevity in your answer.  2.09. What is the ratio of the Grants(current US$) of Eritrea in 1996 to that in 2000?
Provide a short and direct response. 0.87. What is the ratio of the Grants(current US$) in Gabon in 1996 to that in 2000?
Provide a succinct answer. 1.99. What is the ratio of the Grants(current US$) in Iraq in 1996 to that in 2000?
Ensure brevity in your answer.  3.54. What is the ratio of the Grants(current US$) in Cote d'Ivoire in 1996 to that in 2001?
Provide a short and direct response. 2.31. What is the ratio of the Grants(current US$) in Eritrea in 1996 to that in 2001?
Offer a very short reply. 0.61. What is the ratio of the Grants(current US$) of Gabon in 1996 to that in 2001?
Offer a terse response. 2.17. What is the ratio of the Grants(current US$) of Iraq in 1996 to that in 2001?
Keep it short and to the point. 2.89. What is the ratio of the Grants(current US$) in Cote d'Ivoire in 1996 to that in 2002?
Provide a succinct answer. 0.74. What is the ratio of the Grants(current US$) of Eritrea in 1996 to that in 2002?
Provide a succinct answer. 0.77. What is the ratio of the Grants(current US$) of Gabon in 1996 to that in 2002?
Give a very brief answer. 1.39. What is the ratio of the Grants(current US$) in Iraq in 1996 to that in 2002?
Your answer should be compact. 3.15. What is the ratio of the Grants(current US$) of Cote d'Ivoire in 1997 to that in 1998?
Your answer should be very brief. 0.59. What is the ratio of the Grants(current US$) in Eritrea in 1997 to that in 1998?
Your answer should be compact. 0.81. What is the ratio of the Grants(current US$) in Gabon in 1997 to that in 1998?
Provide a succinct answer. 1.12. What is the ratio of the Grants(current US$) of Iraq in 1997 to that in 1998?
Make the answer very short. 2.22. What is the ratio of the Grants(current US$) of Cote d'Ivoire in 1997 to that in 1999?
Keep it short and to the point. 0.83. What is the ratio of the Grants(current US$) in Eritrea in 1997 to that in 1999?
Your answer should be very brief. 0.94. What is the ratio of the Grants(current US$) of Gabon in 1997 to that in 1999?
Keep it short and to the point. 1.53. What is the ratio of the Grants(current US$) of Iraq in 1997 to that in 1999?
Your answer should be very brief. 2.35. What is the ratio of the Grants(current US$) in Cote d'Ivoire in 1997 to that in 2000?
Make the answer very short. 1.28. What is the ratio of the Grants(current US$) of Eritrea in 1997 to that in 2000?
Provide a short and direct response. 0.57. What is the ratio of the Grants(current US$) of Gabon in 1997 to that in 2000?
Offer a terse response. 1.5. What is the ratio of the Grants(current US$) of Iraq in 1997 to that in 2000?
Provide a succinct answer. 2.24. What is the ratio of the Grants(current US$) of Cote d'Ivoire in 1997 to that in 2001?
Your answer should be compact. 1.41. What is the ratio of the Grants(current US$) of Eritrea in 1997 to that in 2001?
Make the answer very short. 0.4. What is the ratio of the Grants(current US$) in Gabon in 1997 to that in 2001?
Provide a short and direct response. 1.63. What is the ratio of the Grants(current US$) in Iraq in 1997 to that in 2001?
Offer a terse response. 1.83. What is the ratio of the Grants(current US$) of Cote d'Ivoire in 1997 to that in 2002?
Your answer should be compact. 0.45. What is the ratio of the Grants(current US$) of Eritrea in 1997 to that in 2002?
Your response must be concise. 0.5. What is the ratio of the Grants(current US$) of Gabon in 1997 to that in 2002?
Provide a short and direct response. 1.04. What is the ratio of the Grants(current US$) in Iraq in 1997 to that in 2002?
Make the answer very short. 2. What is the ratio of the Grants(current US$) in Cote d'Ivoire in 1998 to that in 1999?
Keep it short and to the point. 1.4. What is the ratio of the Grants(current US$) of Eritrea in 1998 to that in 1999?
Keep it short and to the point. 1.15. What is the ratio of the Grants(current US$) of Gabon in 1998 to that in 1999?
Offer a very short reply. 1.36. What is the ratio of the Grants(current US$) of Iraq in 1998 to that in 1999?
Your answer should be compact. 1.06. What is the ratio of the Grants(current US$) in Cote d'Ivoire in 1998 to that in 2000?
Ensure brevity in your answer.  2.16. What is the ratio of the Grants(current US$) in Gabon in 1998 to that in 2000?
Your answer should be compact. 1.33. What is the ratio of the Grants(current US$) of Iraq in 1998 to that in 2000?
Provide a short and direct response. 1.01. What is the ratio of the Grants(current US$) of Cote d'Ivoire in 1998 to that in 2001?
Your answer should be compact. 2.39. What is the ratio of the Grants(current US$) of Eritrea in 1998 to that in 2001?
Provide a short and direct response. 0.49. What is the ratio of the Grants(current US$) of Gabon in 1998 to that in 2001?
Offer a very short reply. 1.45. What is the ratio of the Grants(current US$) in Iraq in 1998 to that in 2001?
Offer a terse response. 0.82. What is the ratio of the Grants(current US$) of Cote d'Ivoire in 1998 to that in 2002?
Keep it short and to the point. 0.76. What is the ratio of the Grants(current US$) in Eritrea in 1998 to that in 2002?
Offer a terse response. 0.62. What is the ratio of the Grants(current US$) in Gabon in 1998 to that in 2002?
Offer a terse response. 0.93. What is the ratio of the Grants(current US$) of Iraq in 1998 to that in 2002?
Your answer should be very brief. 0.9. What is the ratio of the Grants(current US$) of Cote d'Ivoire in 1999 to that in 2000?
Give a very brief answer. 1.54. What is the ratio of the Grants(current US$) in Eritrea in 1999 to that in 2000?
Your answer should be very brief. 0.61. What is the ratio of the Grants(current US$) in Gabon in 1999 to that in 2000?
Keep it short and to the point. 0.98. What is the ratio of the Grants(current US$) in Iraq in 1999 to that in 2000?
Your answer should be very brief. 0.95. What is the ratio of the Grants(current US$) in Cote d'Ivoire in 1999 to that in 2001?
Offer a very short reply. 1.71. What is the ratio of the Grants(current US$) of Eritrea in 1999 to that in 2001?
Provide a short and direct response. 0.43. What is the ratio of the Grants(current US$) in Gabon in 1999 to that in 2001?
Your answer should be very brief. 1.07. What is the ratio of the Grants(current US$) in Iraq in 1999 to that in 2001?
Your response must be concise. 0.78. What is the ratio of the Grants(current US$) of Cote d'Ivoire in 1999 to that in 2002?
Your response must be concise. 0.54. What is the ratio of the Grants(current US$) of Eritrea in 1999 to that in 2002?
Ensure brevity in your answer.  0.54. What is the ratio of the Grants(current US$) of Gabon in 1999 to that in 2002?
Provide a succinct answer. 0.68. What is the ratio of the Grants(current US$) of Iraq in 1999 to that in 2002?
Your answer should be compact. 0.85. What is the ratio of the Grants(current US$) in Cote d'Ivoire in 2000 to that in 2001?
Ensure brevity in your answer.  1.11. What is the ratio of the Grants(current US$) in Eritrea in 2000 to that in 2001?
Offer a terse response. 0.7. What is the ratio of the Grants(current US$) of Gabon in 2000 to that in 2001?
Your answer should be compact. 1.09. What is the ratio of the Grants(current US$) of Iraq in 2000 to that in 2001?
Your answer should be compact. 0.82. What is the ratio of the Grants(current US$) in Cote d'Ivoire in 2000 to that in 2002?
Offer a very short reply. 0.35. What is the ratio of the Grants(current US$) of Eritrea in 2000 to that in 2002?
Give a very brief answer. 0.88. What is the ratio of the Grants(current US$) of Gabon in 2000 to that in 2002?
Your response must be concise. 0.7. What is the ratio of the Grants(current US$) of Iraq in 2000 to that in 2002?
Provide a succinct answer. 0.89. What is the ratio of the Grants(current US$) in Cote d'Ivoire in 2001 to that in 2002?
Your response must be concise. 0.32. What is the ratio of the Grants(current US$) of Eritrea in 2001 to that in 2002?
Your answer should be compact. 1.25. What is the ratio of the Grants(current US$) in Gabon in 2001 to that in 2002?
Your response must be concise. 0.64. What is the ratio of the Grants(current US$) in Iraq in 2001 to that in 2002?
Your answer should be compact. 1.09. What is the difference between the highest and the second highest Grants(current US$) of Cote d'Ivoire?
Provide a succinct answer. 1.60e+08. What is the difference between the highest and the second highest Grants(current US$) in Eritrea?
Provide a short and direct response. 3.05e+07. What is the difference between the highest and the second highest Grants(current US$) in Gabon?
Your answer should be compact. 1.92e+07. What is the difference between the highest and the second highest Grants(current US$) of Iraq?
Your response must be concise. 1.21e+08. What is the difference between the highest and the lowest Grants(current US$) of Cote d'Ivoire?
Your answer should be very brief. 4.58e+08. What is the difference between the highest and the lowest Grants(current US$) of Eritrea?
Give a very brief answer. 9.04e+07. What is the difference between the highest and the lowest Grants(current US$) of Gabon?
Your response must be concise. 4.18e+07. What is the difference between the highest and the lowest Grants(current US$) of Iraq?
Provide a short and direct response. 2.42e+08. 